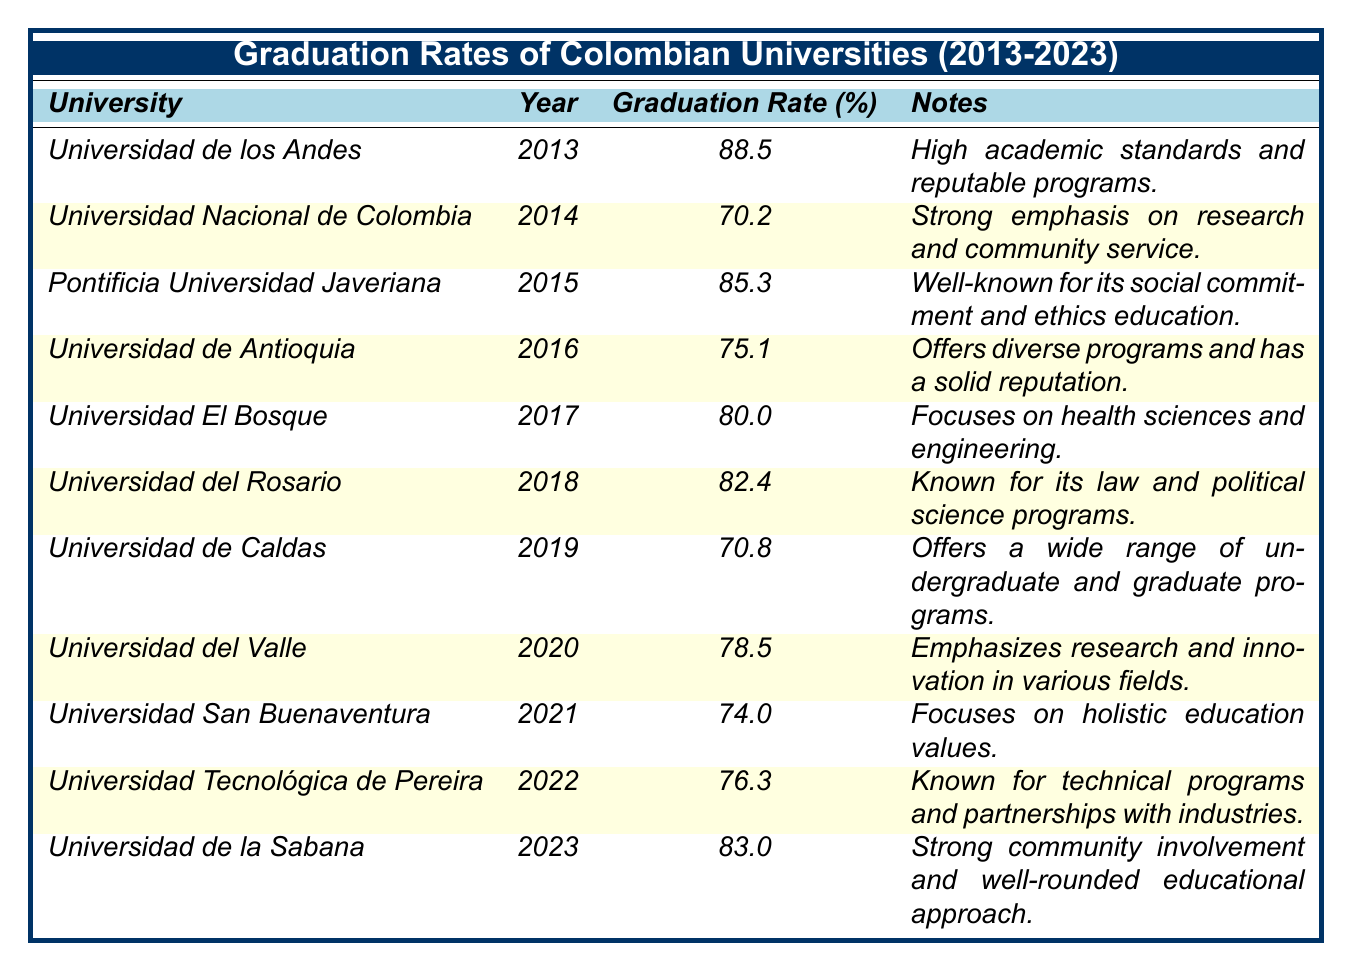What is the graduation rate of Universidad de los Andes in 2013? The table shows that Universidad de los Andes had a graduation rate of 88.5% in the year 2013.
Answer: 88.5% Which university had the lowest graduation rate, and what was the rate? By examining the table, Universidad Nacional de Colombia in 2014 has the lowest graduation rate of 70.2%.
Answer: Universidad Nacional de Colombia, 70.2% What percentage did the graduation rate increase from 2014 to 2015? The graduation rate for Universidad Nacional de Colombia in 2014 was 70.2%, while for Pontificia Universidad Javeriana in 2015 it was 85.3%. The increase is calculated as 85.3 - 70.2 = 15.1%.
Answer: 15.1% Which year saw the highest graduation rate, and what was that rate? The highest graduation rate recorded in the table was 88.5% for Universidad de los Andes in 2013.
Answer: 2013, 88.5% Is it true that Universidad del Valle's graduation rate is higher than that of Universidad de Caldas? In 2020, Universidad del Valle had a graduation rate of 78.5%, and Universidad de Caldas in 2019 had a rate of 70.8%, so it is true.
Answer: Yes What is the average graduation rate from 2013 to 2023 based on the universities listed? To calculate the average, add all graduation rates: 88.5 + 70.2 + 85.3 + 75.1 + 80.0 + 82.4 + 70.8 + 78.5 + 74.0 + 76.3 + 83.0 =  83.1, then divide by 11 (the number of years):  83.1 / 11 ≈ 76.9.
Answer: 76.9 How does the graduation rate of Universidad de la Sabana in 2023 compare to that of Universidad San Buenaventura in 2021? Universidad de la Sabana had a graduation rate of 83.0% in 2023, while Universidad San Buenaventura had a rate of 74.0% in 2021. Since 83.0% is greater than 74.0%, Universidad de la Sabana has a higher graduation rate.
Answer: Higher Which university shows a consistent increase in graduation rates over the years based on the data? To determine if a university shows consistent increase, we compare rates year by year. The rates vary; however, a straightforward observation shows that Universidad de los Andes had the highest and consistent rates in 2013. Other universities do not display a continuous increasing pattern, indicating it may not be applicable that any university consistently increased.
Answer: No consistent increase 